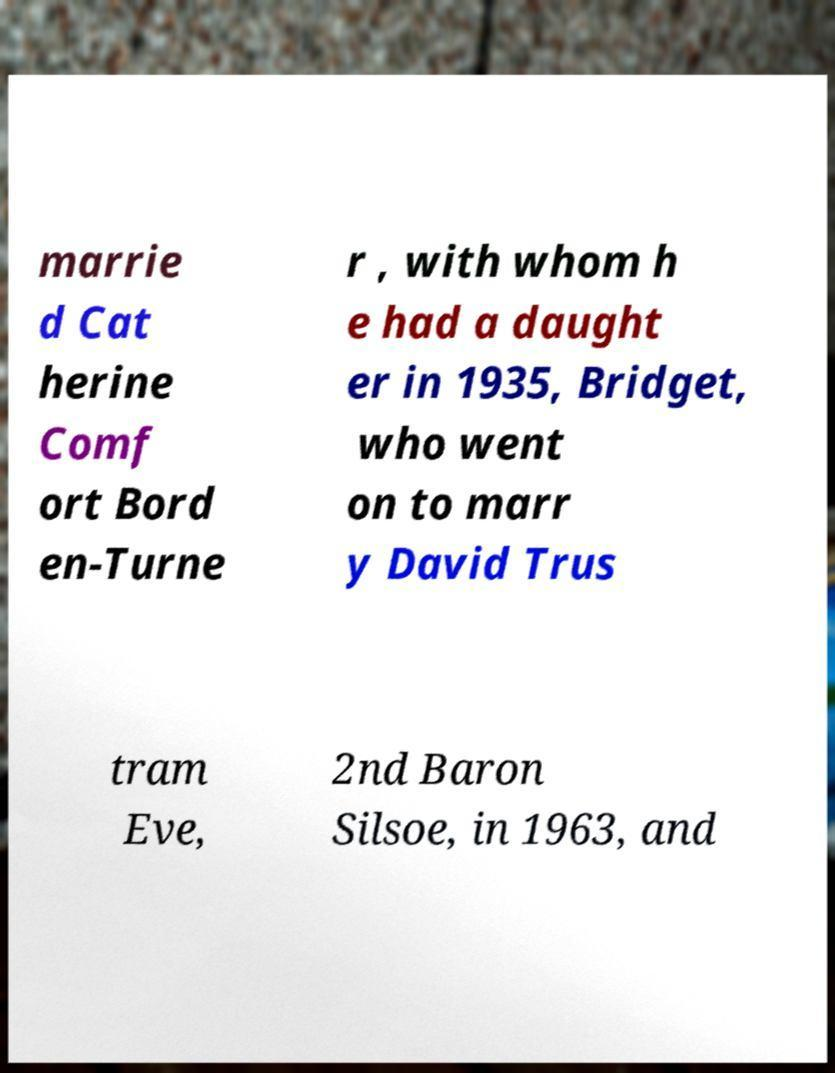For documentation purposes, I need the text within this image transcribed. Could you provide that? marrie d Cat herine Comf ort Bord en-Turne r , with whom h e had a daught er in 1935, Bridget, who went on to marr y David Trus tram Eve, 2nd Baron Silsoe, in 1963, and 